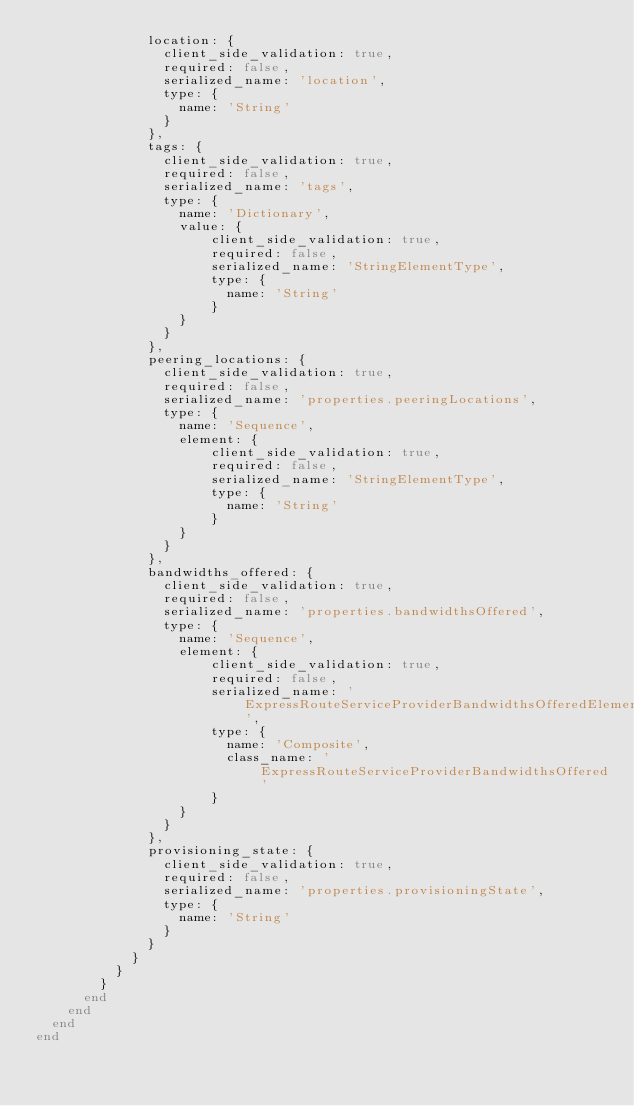<code> <loc_0><loc_0><loc_500><loc_500><_Ruby_>              location: {
                client_side_validation: true,
                required: false,
                serialized_name: 'location',
                type: {
                  name: 'String'
                }
              },
              tags: {
                client_side_validation: true,
                required: false,
                serialized_name: 'tags',
                type: {
                  name: 'Dictionary',
                  value: {
                      client_side_validation: true,
                      required: false,
                      serialized_name: 'StringElementType',
                      type: {
                        name: 'String'
                      }
                  }
                }
              },
              peering_locations: {
                client_side_validation: true,
                required: false,
                serialized_name: 'properties.peeringLocations',
                type: {
                  name: 'Sequence',
                  element: {
                      client_side_validation: true,
                      required: false,
                      serialized_name: 'StringElementType',
                      type: {
                        name: 'String'
                      }
                  }
                }
              },
              bandwidths_offered: {
                client_side_validation: true,
                required: false,
                serialized_name: 'properties.bandwidthsOffered',
                type: {
                  name: 'Sequence',
                  element: {
                      client_side_validation: true,
                      required: false,
                      serialized_name: 'ExpressRouteServiceProviderBandwidthsOfferedElementType',
                      type: {
                        name: 'Composite',
                        class_name: 'ExpressRouteServiceProviderBandwidthsOffered'
                      }
                  }
                }
              },
              provisioning_state: {
                client_side_validation: true,
                required: false,
                serialized_name: 'properties.provisioningState',
                type: {
                  name: 'String'
                }
              }
            }
          }
        }
      end
    end
  end
end
</code> 